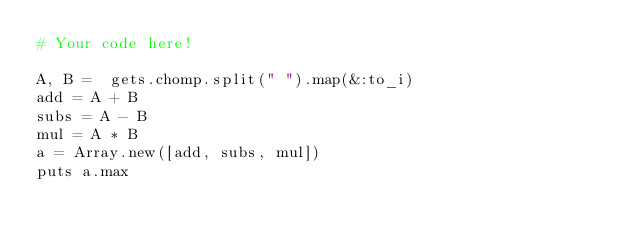Convert code to text. <code><loc_0><loc_0><loc_500><loc_500><_Ruby_># Your code here!

A, B =  gets.chomp.split(" ").map(&:to_i)
add = A + B
subs = A - B
mul = A * B
a = Array.new([add, subs, mul])
puts a.max
</code> 